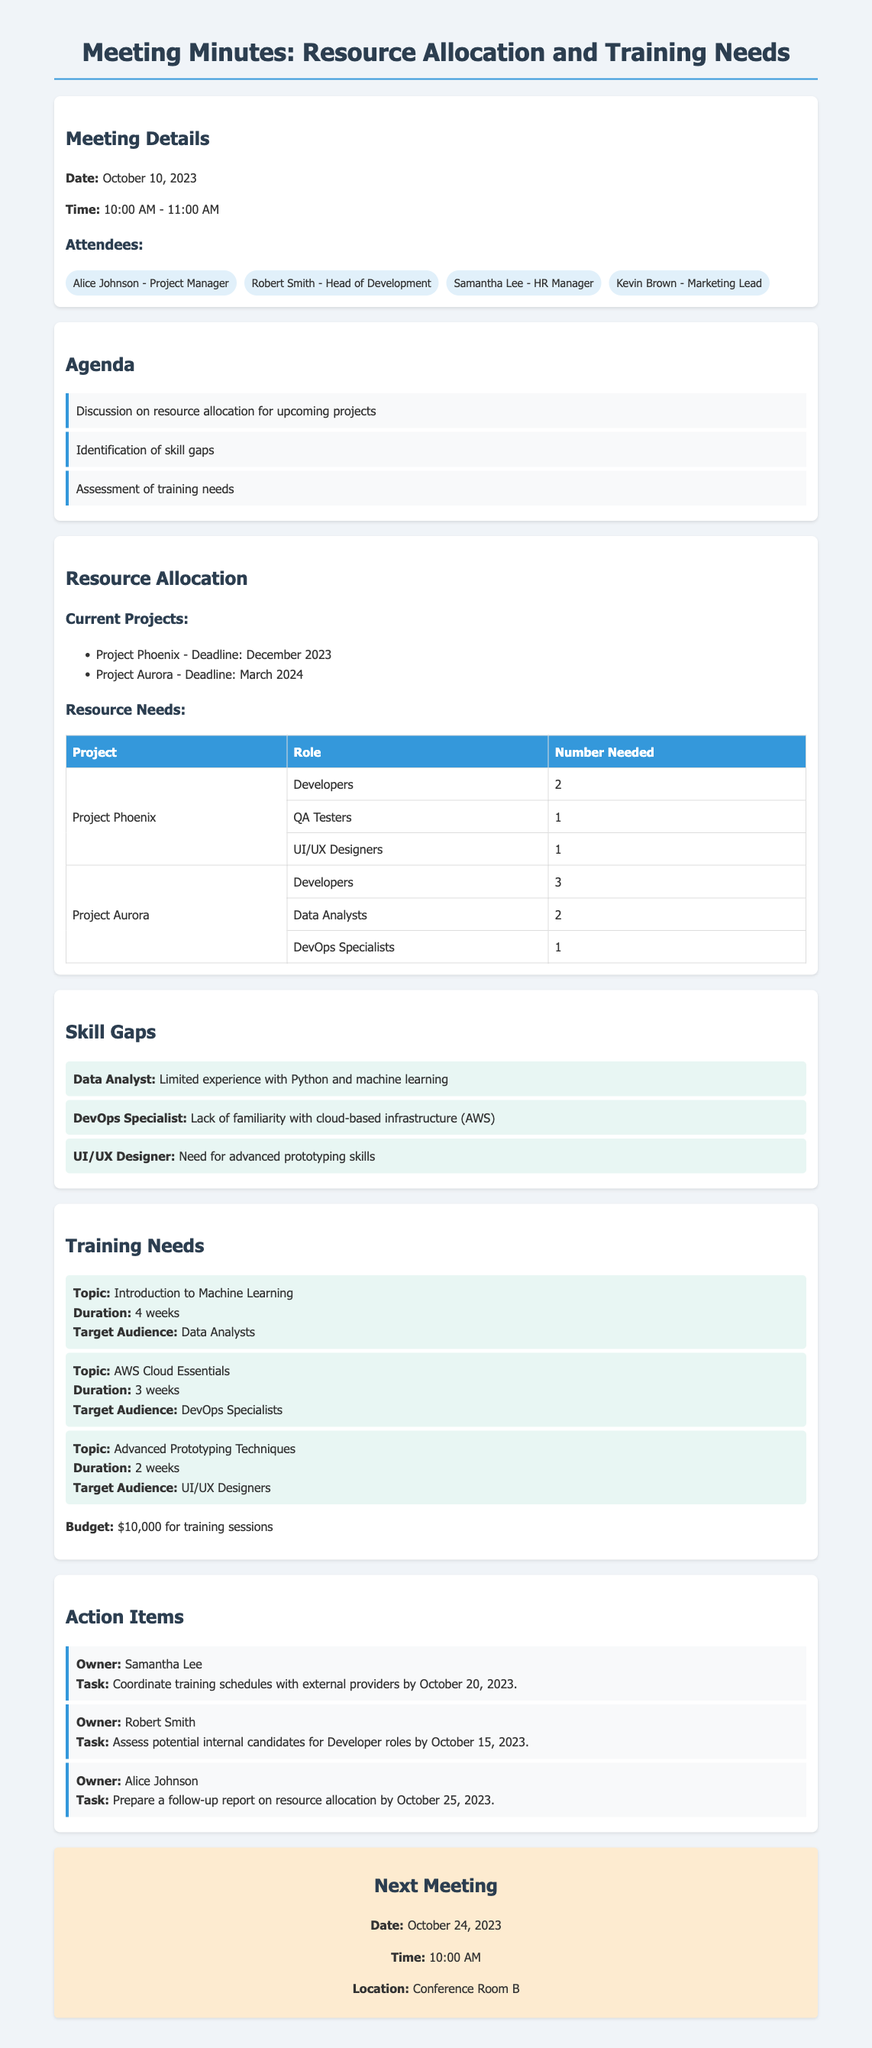What is the date of the meeting? The date of the meeting is explicitly stated in the meeting details section.
Answer: October 10, 2023 Who is the head of development? The document lists the attendees, including the role and name of the head of development.
Answer: Robert Smith How many developers are needed for Project Aurora? The resource allocation table specifies the number of developers required for each project.
Answer: 3 What is the total budget for training sessions? The budget for training sessions is mentioned in the training needs section.
Answer: $10,000 What skill gap was identified for the Data Analyst role? The skill gaps section points out the specific limitations for the Data Analyst role.
Answer: Limited experience with Python and machine learning Which training session is targeted at UI/UX Designers? The training needs section includes specific training topics for each role.
Answer: Advanced Prototyping Techniques What action is assigned to Samantha Lee? The action items section details tasks assigned to different individuals.
Answer: Coordinate training schedules with external providers by October 20, 2023 When is the next meeting scheduled? The next meeting details are provided towards the end of the document.
Answer: October 24, 2023 What is the duration of the AWS Cloud Essentials training? The duration of the training session is listed in the training needs section.
Answer: 3 weeks 